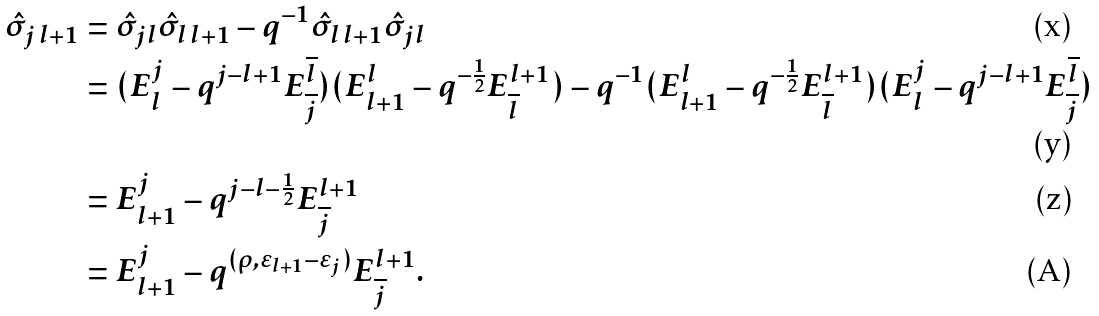<formula> <loc_0><loc_0><loc_500><loc_500>\hat { \sigma } _ { j \, l + 1 } & = \hat { \sigma } _ { j l } \hat { \sigma } _ { l \, l + 1 } - q ^ { - 1 } \hat { \sigma } _ { l \, l + 1 } \hat { \sigma } _ { j l } \\ & = ( E ^ { j } _ { l } - q ^ { j - l + 1 } E ^ { \overline { l } } _ { \overline { j } } ) ( E ^ { l } _ { l + 1 } - q ^ { - \frac { 1 } { 2 } } E ^ { l + 1 } _ { \overline { l } } ) - q ^ { - 1 } ( E ^ { l } _ { l + 1 } - q ^ { - \frac { 1 } { 2 } } E ^ { l + 1 } _ { \overline { l } } ) ( E ^ { j } _ { l } - q ^ { j - l + 1 } E ^ { \overline { l } } _ { \overline { j } } ) \\ & = E ^ { j } _ { l + 1 } - q ^ { j - l - \frac { 1 } { 2 } } E ^ { l + 1 } _ { \overline { j } } \\ & = E ^ { j } _ { l + 1 } - q ^ { ( \rho , \varepsilon _ { l + 1 } - \varepsilon _ { j } ) } E ^ { l + 1 } _ { \overline { j } } .</formula> 